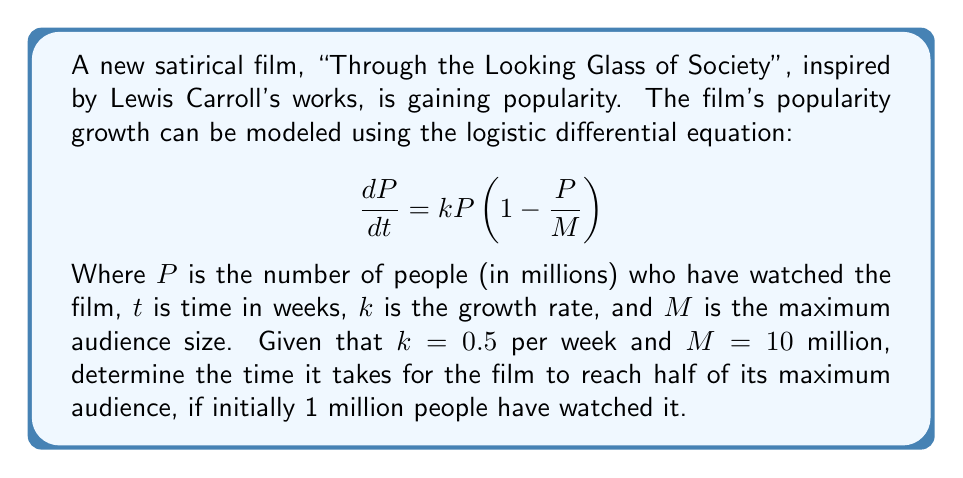Can you solve this math problem? Let's approach this step-by-step:

1) The logistic equation is given by:

   $$\frac{dP}{dt} = kP(1-\frac{P}{M})$$

2) We're given that $k=0.5$, $M=10$, and initially $P(0)=1$ (all in millions).

3) We need to find $t$ when $P=M/2=5$ million.

4) The solution to the logistic equation is:

   $$P(t) = \frac{M}{1 + (\frac{M}{P_0} - 1)e^{-kt}}$$

   Where $P_0$ is the initial population.

5) Substituting our values:

   $$P(t) = \frac{10}{1 + (10 - 1)e^{-0.5t}}$$

6) We want to find $t$ when $P(t) = 5$:

   $$5 = \frac{10}{1 + 9e^{-0.5t}}$$

7) Solving for $t$:

   $$1 + 9e^{-0.5t} = 2$$
   $$9e^{-0.5t} = 1$$
   $$e^{-0.5t} = \frac{1}{9}$$
   $$-0.5t = \ln(\frac{1}{9}) = -\ln(9)$$
   $$t = \frac{2\ln(9)}{0.5} = 4\ln(9) \approx 8.78$$

Therefore, it takes approximately 8.78 weeks for the film to reach half of its maximum audience.
Answer: $t \approx 8.78$ weeks 